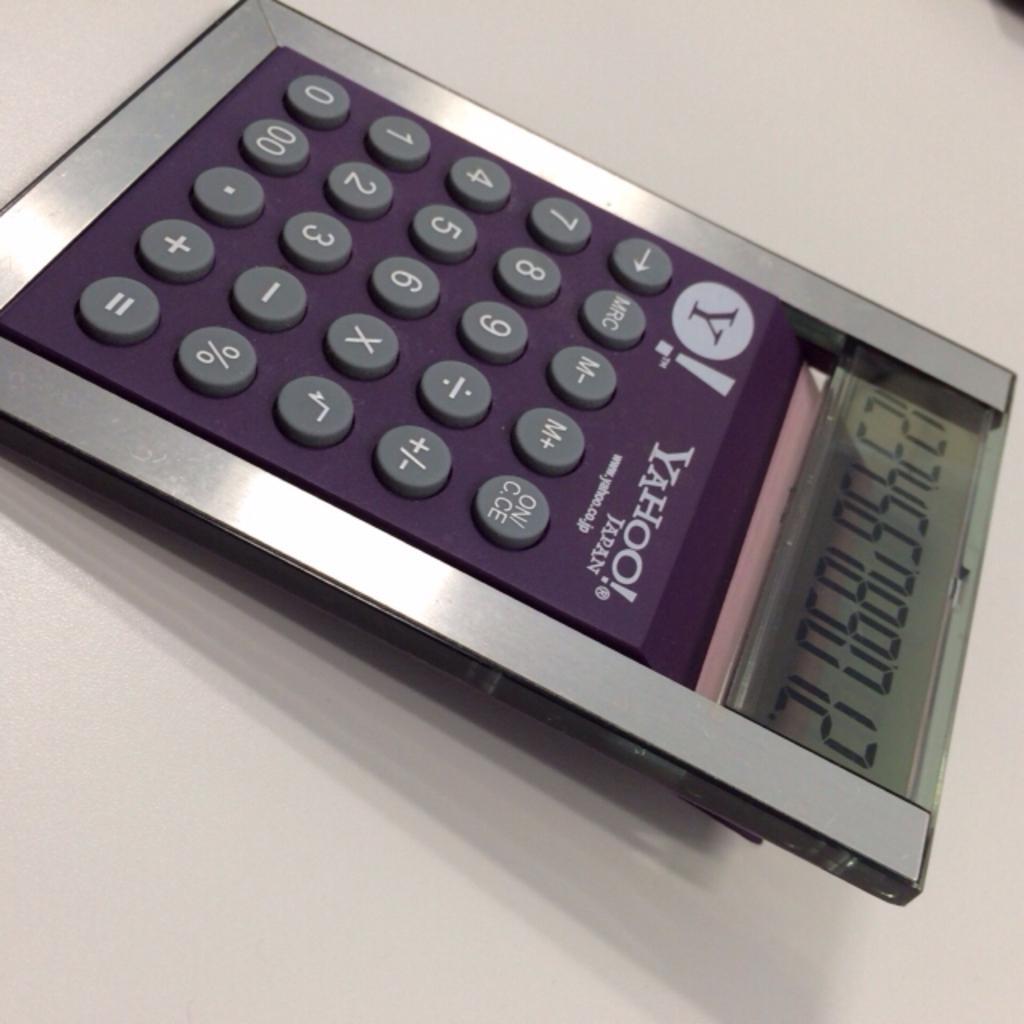Could you give a brief overview of what you see in this image? In this picture there is a calculator on the table. There is a screen on the screen there are numbers and there is a text and logo and there are buttons with numbers and signs on the calculator. 